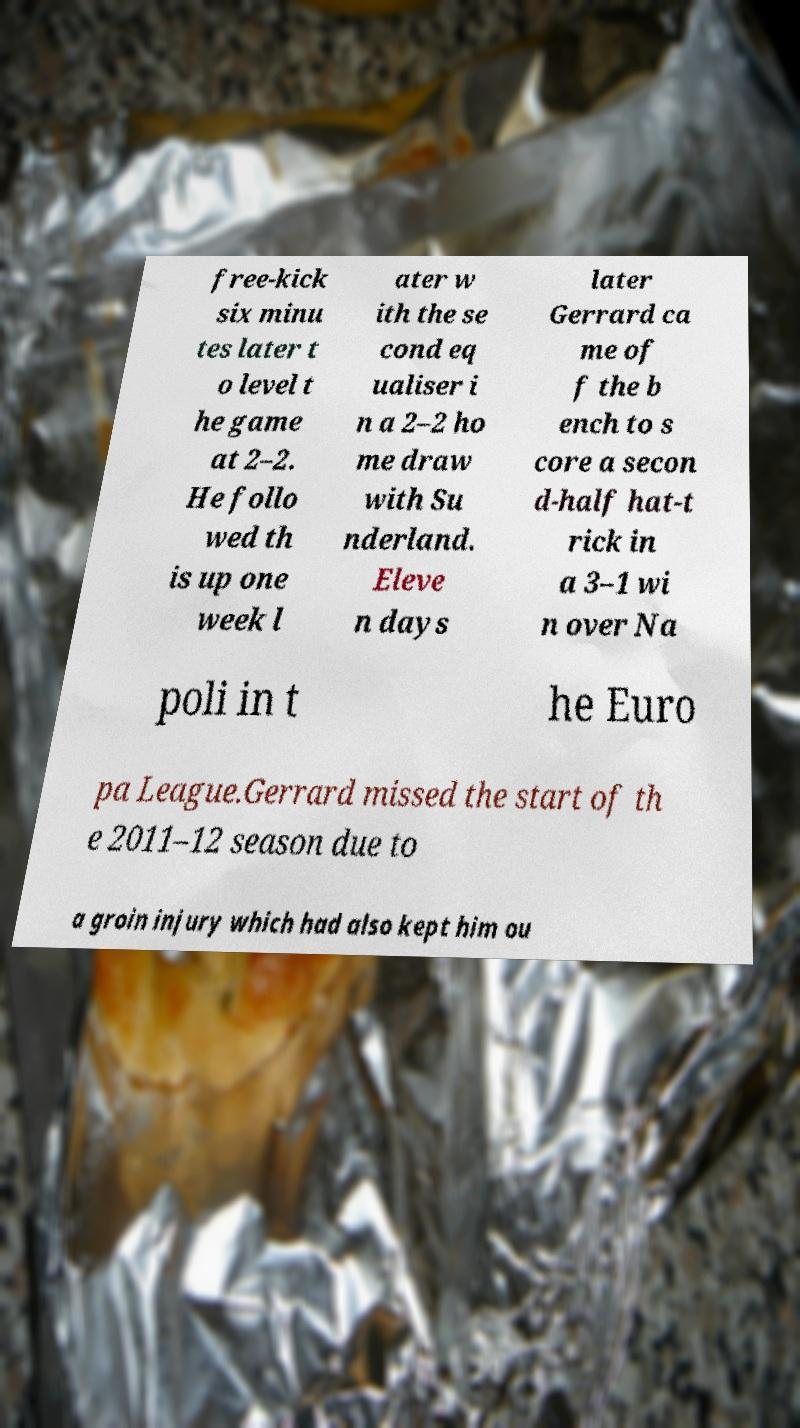For documentation purposes, I need the text within this image transcribed. Could you provide that? free-kick six minu tes later t o level t he game at 2–2. He follo wed th is up one week l ater w ith the se cond eq ualiser i n a 2–2 ho me draw with Su nderland. Eleve n days later Gerrard ca me of f the b ench to s core a secon d-half hat-t rick in a 3–1 wi n over Na poli in t he Euro pa League.Gerrard missed the start of th e 2011–12 season due to a groin injury which had also kept him ou 